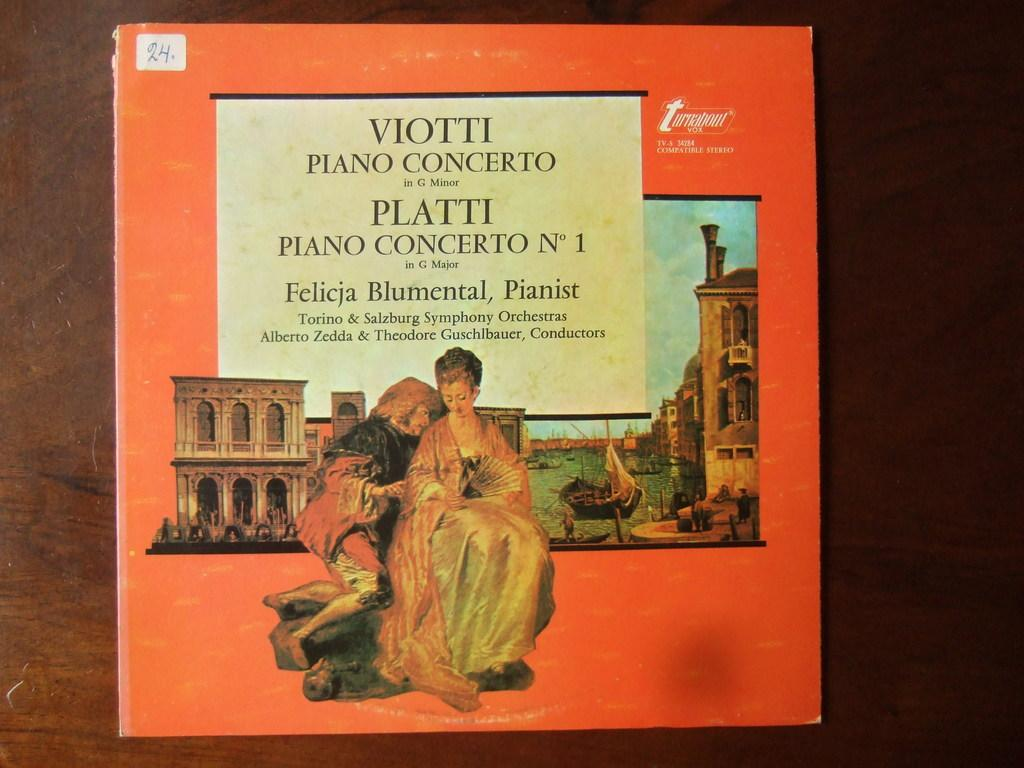<image>
Provide a brief description of the given image. An album of a piano concerto with an orange cover and images of an ancient city. 